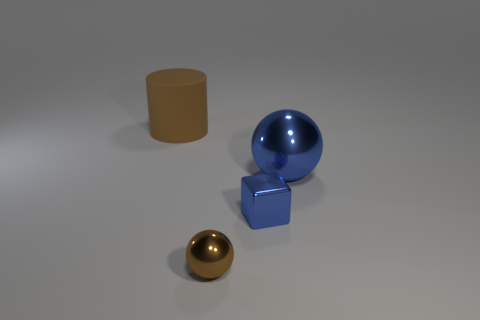Add 4 small blue rubber spheres. How many objects exist? 8 Subtract all cylinders. How many objects are left? 3 Subtract 0 yellow spheres. How many objects are left? 4 Subtract all big cylinders. Subtract all large brown things. How many objects are left? 2 Add 4 big brown cylinders. How many big brown cylinders are left? 5 Add 1 large brown matte objects. How many large brown matte objects exist? 2 